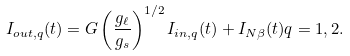Convert formula to latex. <formula><loc_0><loc_0><loc_500><loc_500>I _ { o u t , q } ( t ) = G \left ( \frac { g _ { \ell } } { g _ { s } } \right ) ^ { 1 / 2 } I _ { i n , q } ( t ) + I _ { N \beta } ( t ) q = 1 , 2 .</formula> 